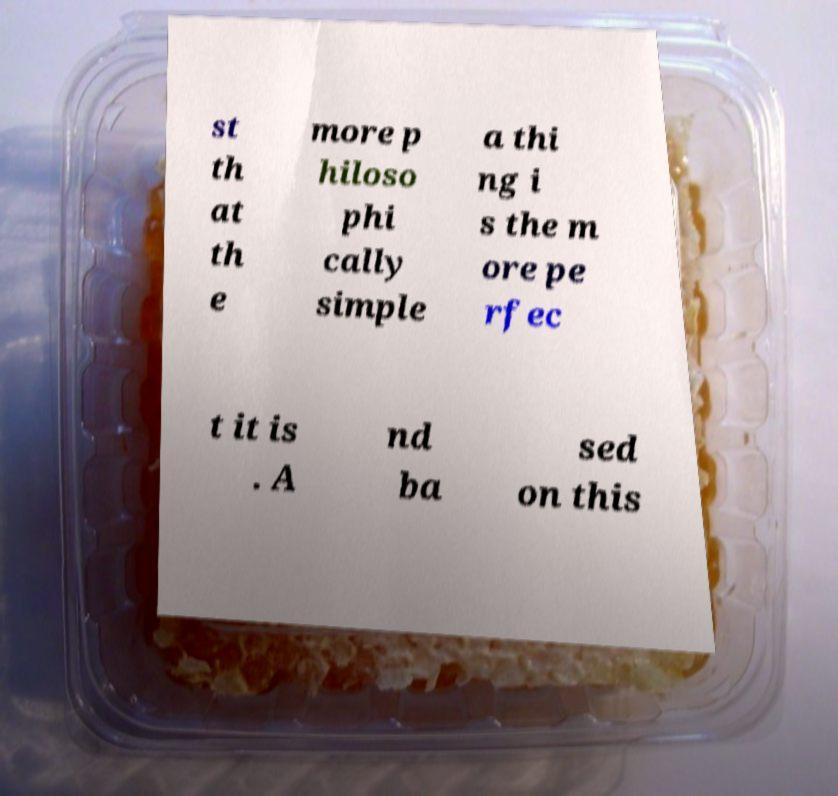Can you read and provide the text displayed in the image?This photo seems to have some interesting text. Can you extract and type it out for me? st th at th e more p hiloso phi cally simple a thi ng i s the m ore pe rfec t it is . A nd ba sed on this 